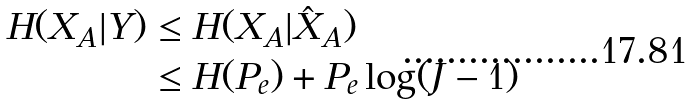Convert formula to latex. <formula><loc_0><loc_0><loc_500><loc_500>H ( X _ { A } | Y ) & \leq H ( X _ { A } | \hat { X } _ { A } ) \\ & \leq H ( P _ { e } ) + P _ { e } \log ( J - 1 )</formula> 